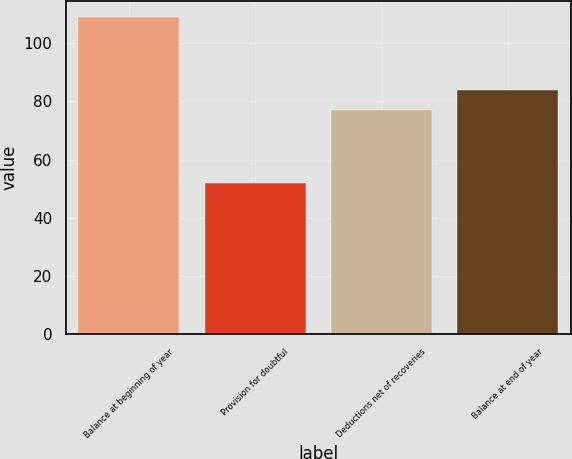<chart> <loc_0><loc_0><loc_500><loc_500><bar_chart><fcel>Balance at beginning of year<fcel>Provision for doubtful<fcel>Deductions net of recoveries<fcel>Balance at end of year<nl><fcel>109<fcel>52<fcel>77<fcel>84<nl></chart> 